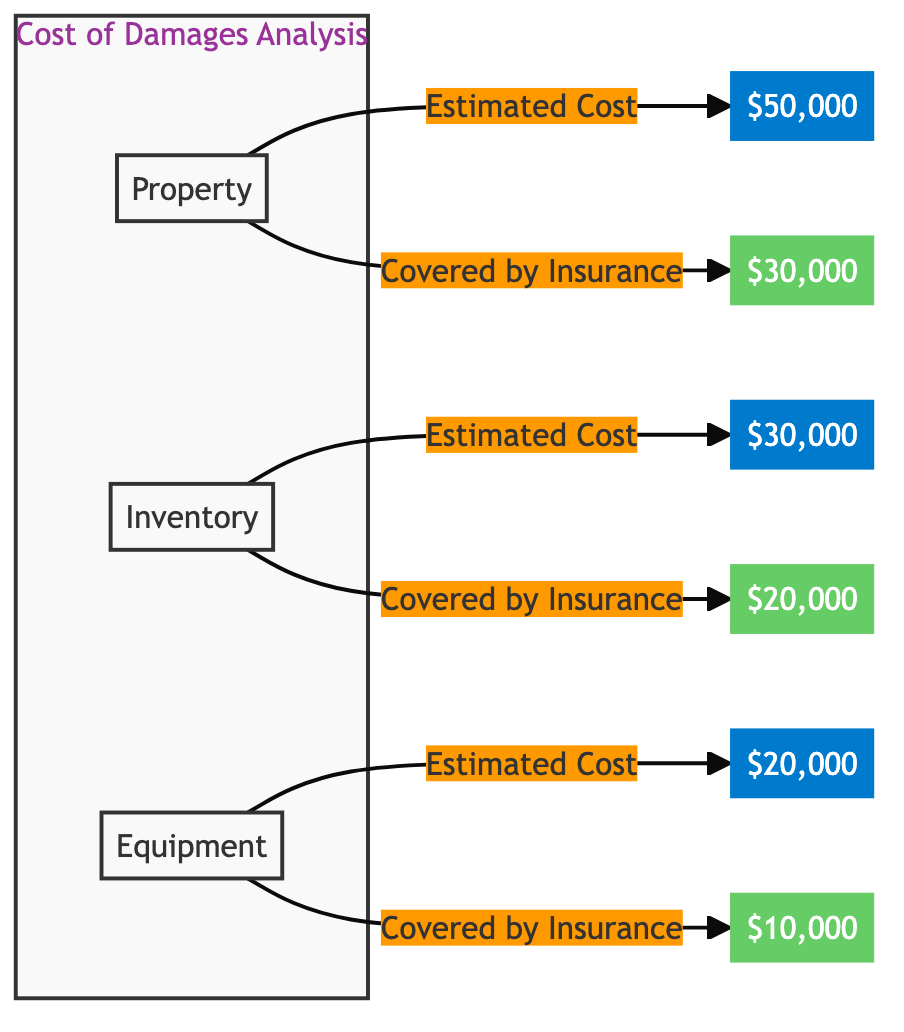What is the estimated cost of property damage? The diagram shows the estimated cost of property damage as a label leading to the amount $50,000.
Answer: $50,000 What is the amount covered by insurance for equipment? The diagram indicates the covered amount for equipment as $10,000 depicted in the corresponding node.
Answer: $10,000 Which type of damage has the highest estimated cost? By comparing the estimated costs displayed, property damage shows the highest amount at $50,000, more than inventory and equipment.
Answer: Property How much total estimated damages does the business incur? The total estimated damages can be calculated by summing the estimated costs: $50,000 (property) + $30,000 (inventory) + $20,000 (equipment) equals $100,000.
Answer: $100,000 What is the total amount covered by all insurance policies? Adding the covered amounts together gives: $30,000 (property) + $20,000 (inventory) + $10,000 (equipment), which equals $60,000.
Answer: $60,000 What percentage of the estimated cost for inventory is covered by insurance? The amount covered by insurance for inventory ($20,000) over its estimated cost ($30,000) is calculated as (20,000 / 30,000) * 100 = 66.67%.
Answer: 66.67% How many distinct types of damages are represented in the diagram? The diagram displays three distinct types of damages: property, inventory, and equipment, making a total of three.
Answer: 3 What is the difference between the estimated cost and the amount covered for property damage? The difference is calculated as the estimated cost of property damage ($50,000) minus the amount covered by insurance ($30,000), resulting in a difference of $20,000.
Answer: $20,000 Which damage type has the lowest coverage percentage? Inventory has an insurance coverage of $20,000 on an estimated cost of $30,000, which is (20,000 / 30,000) * 100 = 66.67%, while equipment has a lower percentage of (10,000 / 20,000) * 100 = 50%.
Answer: Equipment 